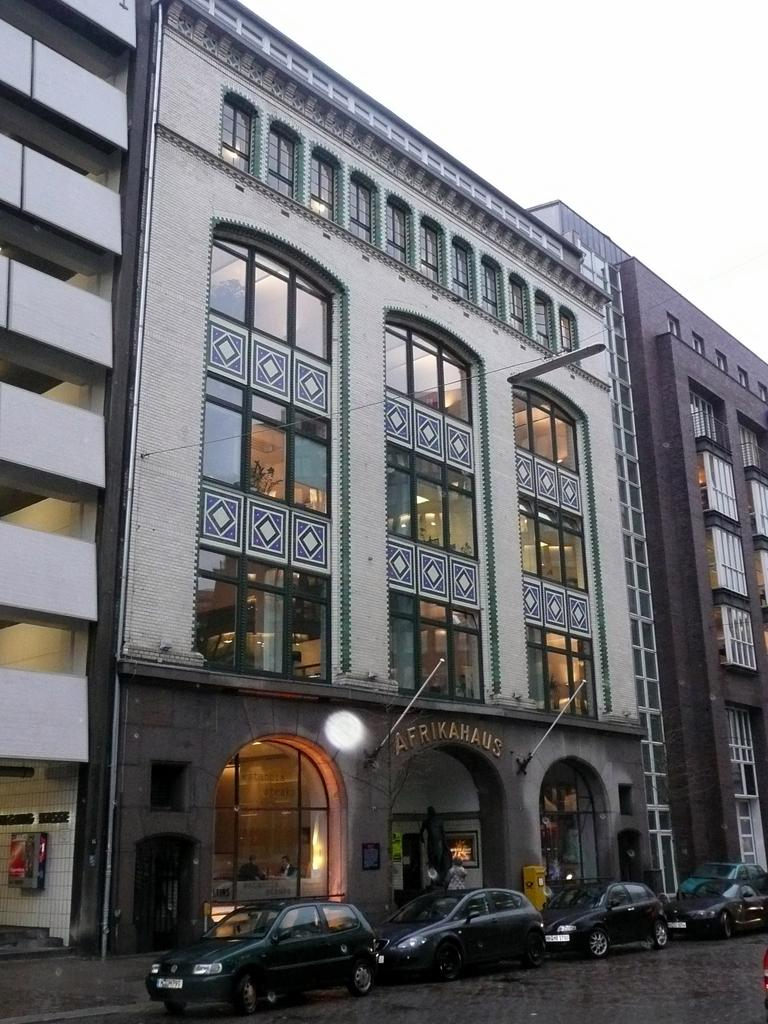What type of vehicles can be seen on the road in the image? There are cars on the road in the image. What structures are visible in the image? There are buildings visible in the image. What part of the natural environment is visible in the image? The sky is visible in the background of the image. Reasoning: Let'g: Let's think step by step in order to produce the conversation. We start by identifying the main subjects in the image, which are the cars on the road. Then, we expand the conversation to include other elements that are also visible, such as the buildings and the sky. Each question is designed to elicit a specific detail about the image that is known from the provided facts. Absurd Question/Answer: What type of religious cloth is being discussed in the image? There is no mention of any religious cloth or discussion in the image. The image primarily features cars on the road and buildings in the background. 